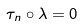<formula> <loc_0><loc_0><loc_500><loc_500>\tau _ { n } \circ \lambda = 0</formula> 